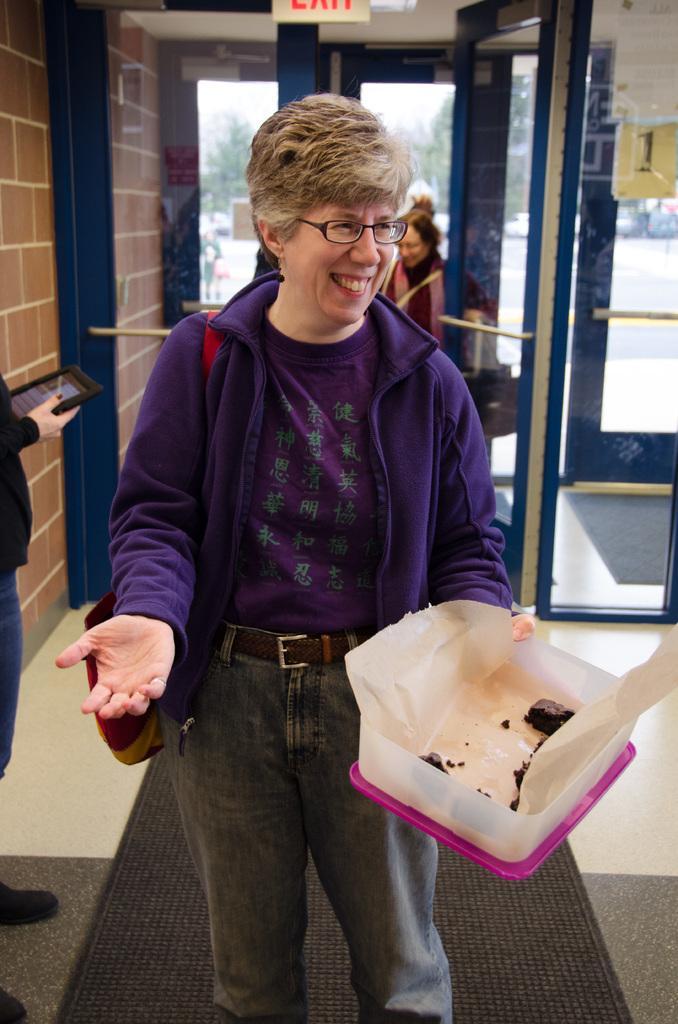Please provide a concise description of this image. In the image there is an old woman in purple dress holding a box, behind her there are few persons visible behind and in front of the glass door with a wall on the left side. 